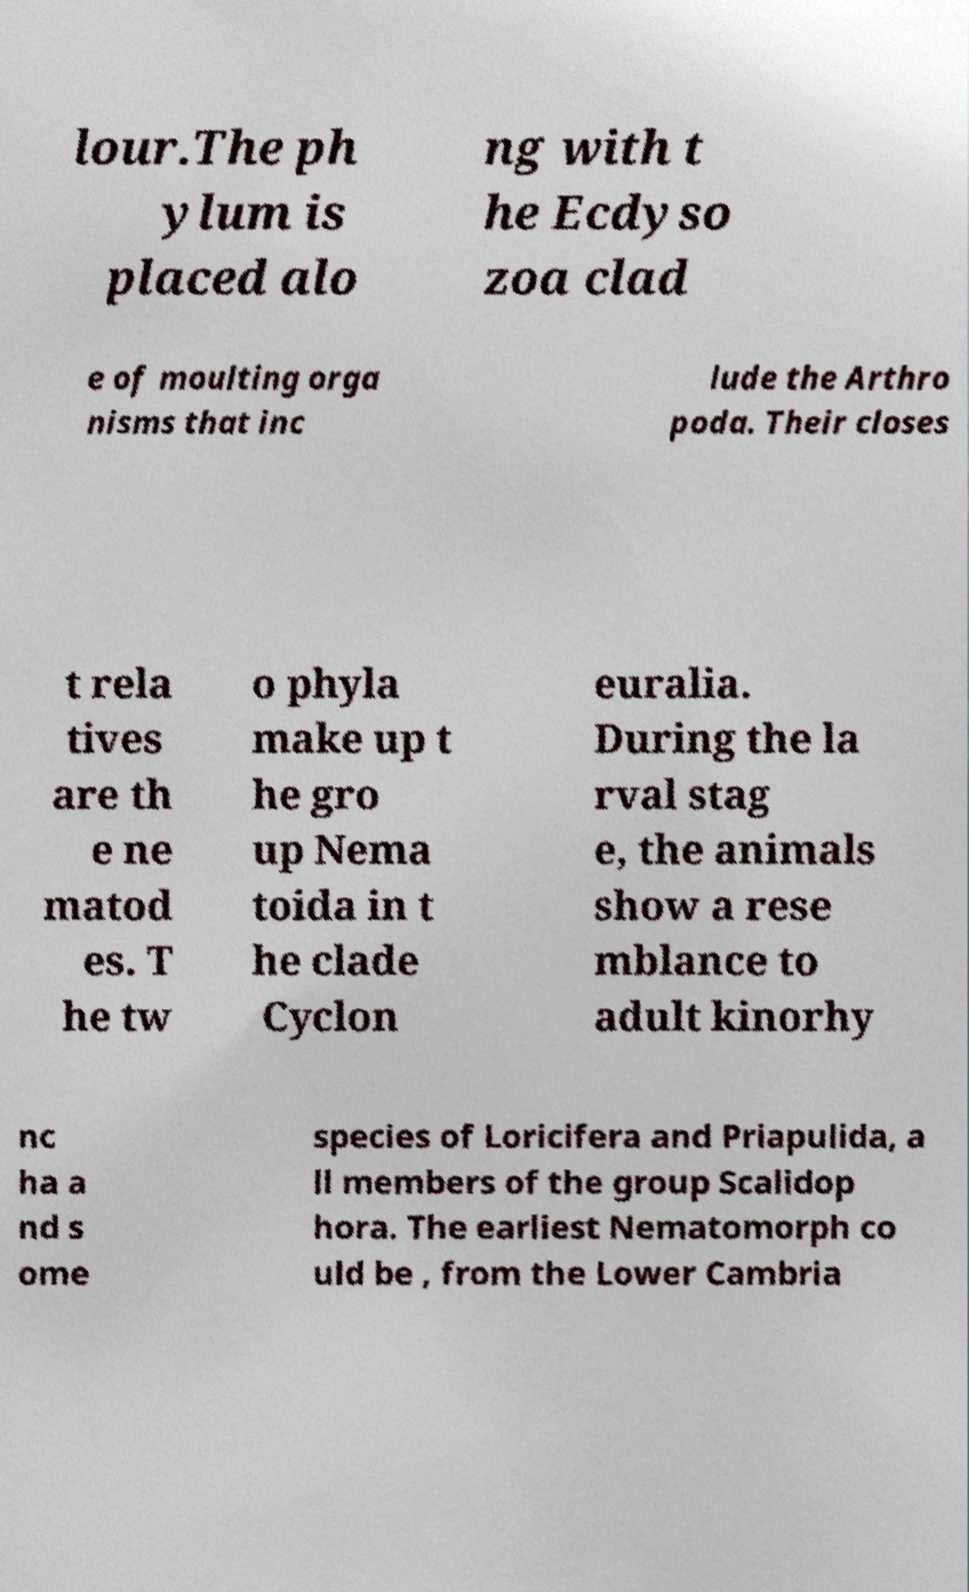I need the written content from this picture converted into text. Can you do that? lour.The ph ylum is placed alo ng with t he Ecdyso zoa clad e of moulting orga nisms that inc lude the Arthro poda. Their closes t rela tives are th e ne matod es. T he tw o phyla make up t he gro up Nema toida in t he clade Cyclon euralia. During the la rval stag e, the animals show a rese mblance to adult kinorhy nc ha a nd s ome species of Loricifera and Priapulida, a ll members of the group Scalidop hora. The earliest Nematomorph co uld be , from the Lower Cambria 